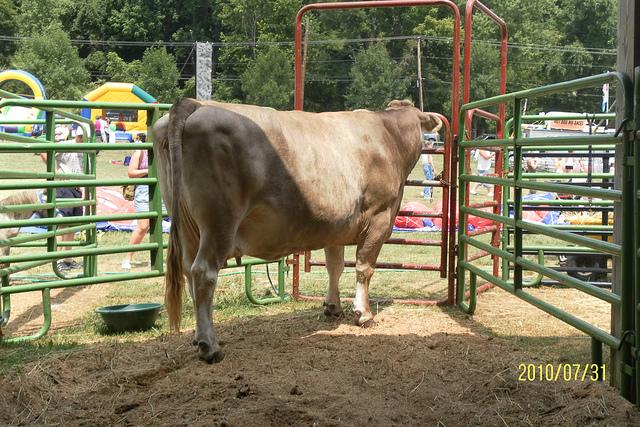What month was this picture taken in?
Concise answer only. July. Are children playing beyond the fence?
Give a very brief answer. Yes. What color is the gate?
Write a very short answer. Red. 